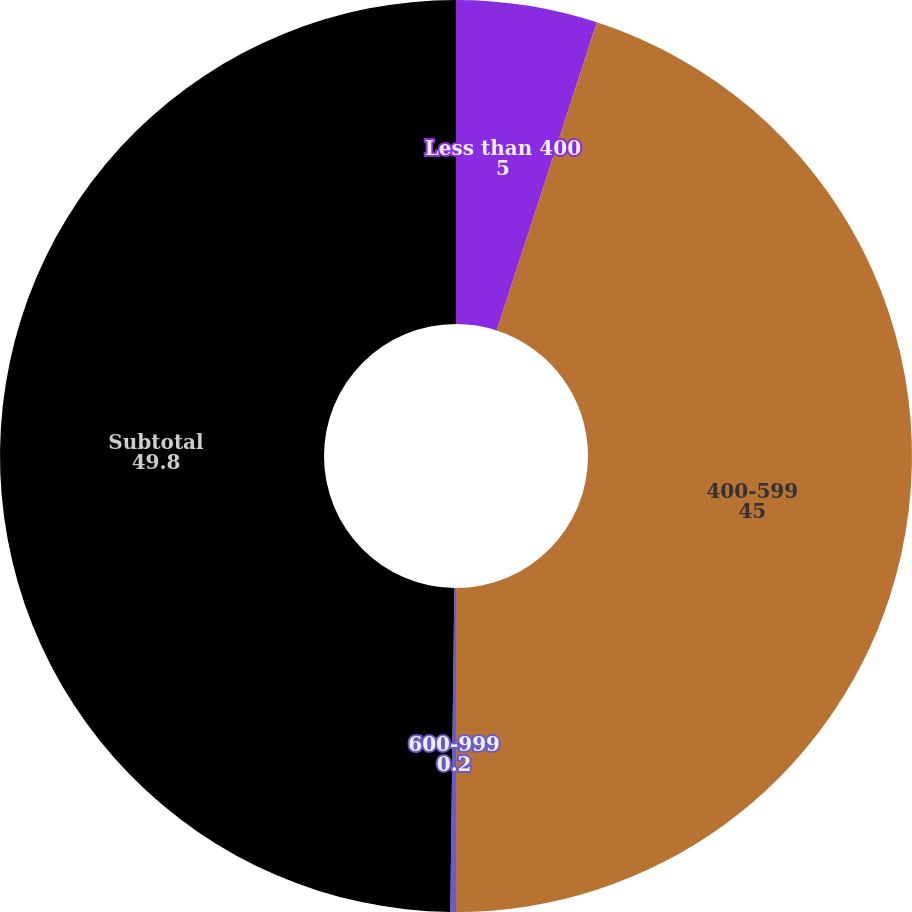<chart> <loc_0><loc_0><loc_500><loc_500><pie_chart><fcel>Less than 400<fcel>400-599<fcel>600-999<fcel>Subtotal<nl><fcel>5.0%<fcel>45.0%<fcel>0.2%<fcel>49.8%<nl></chart> 